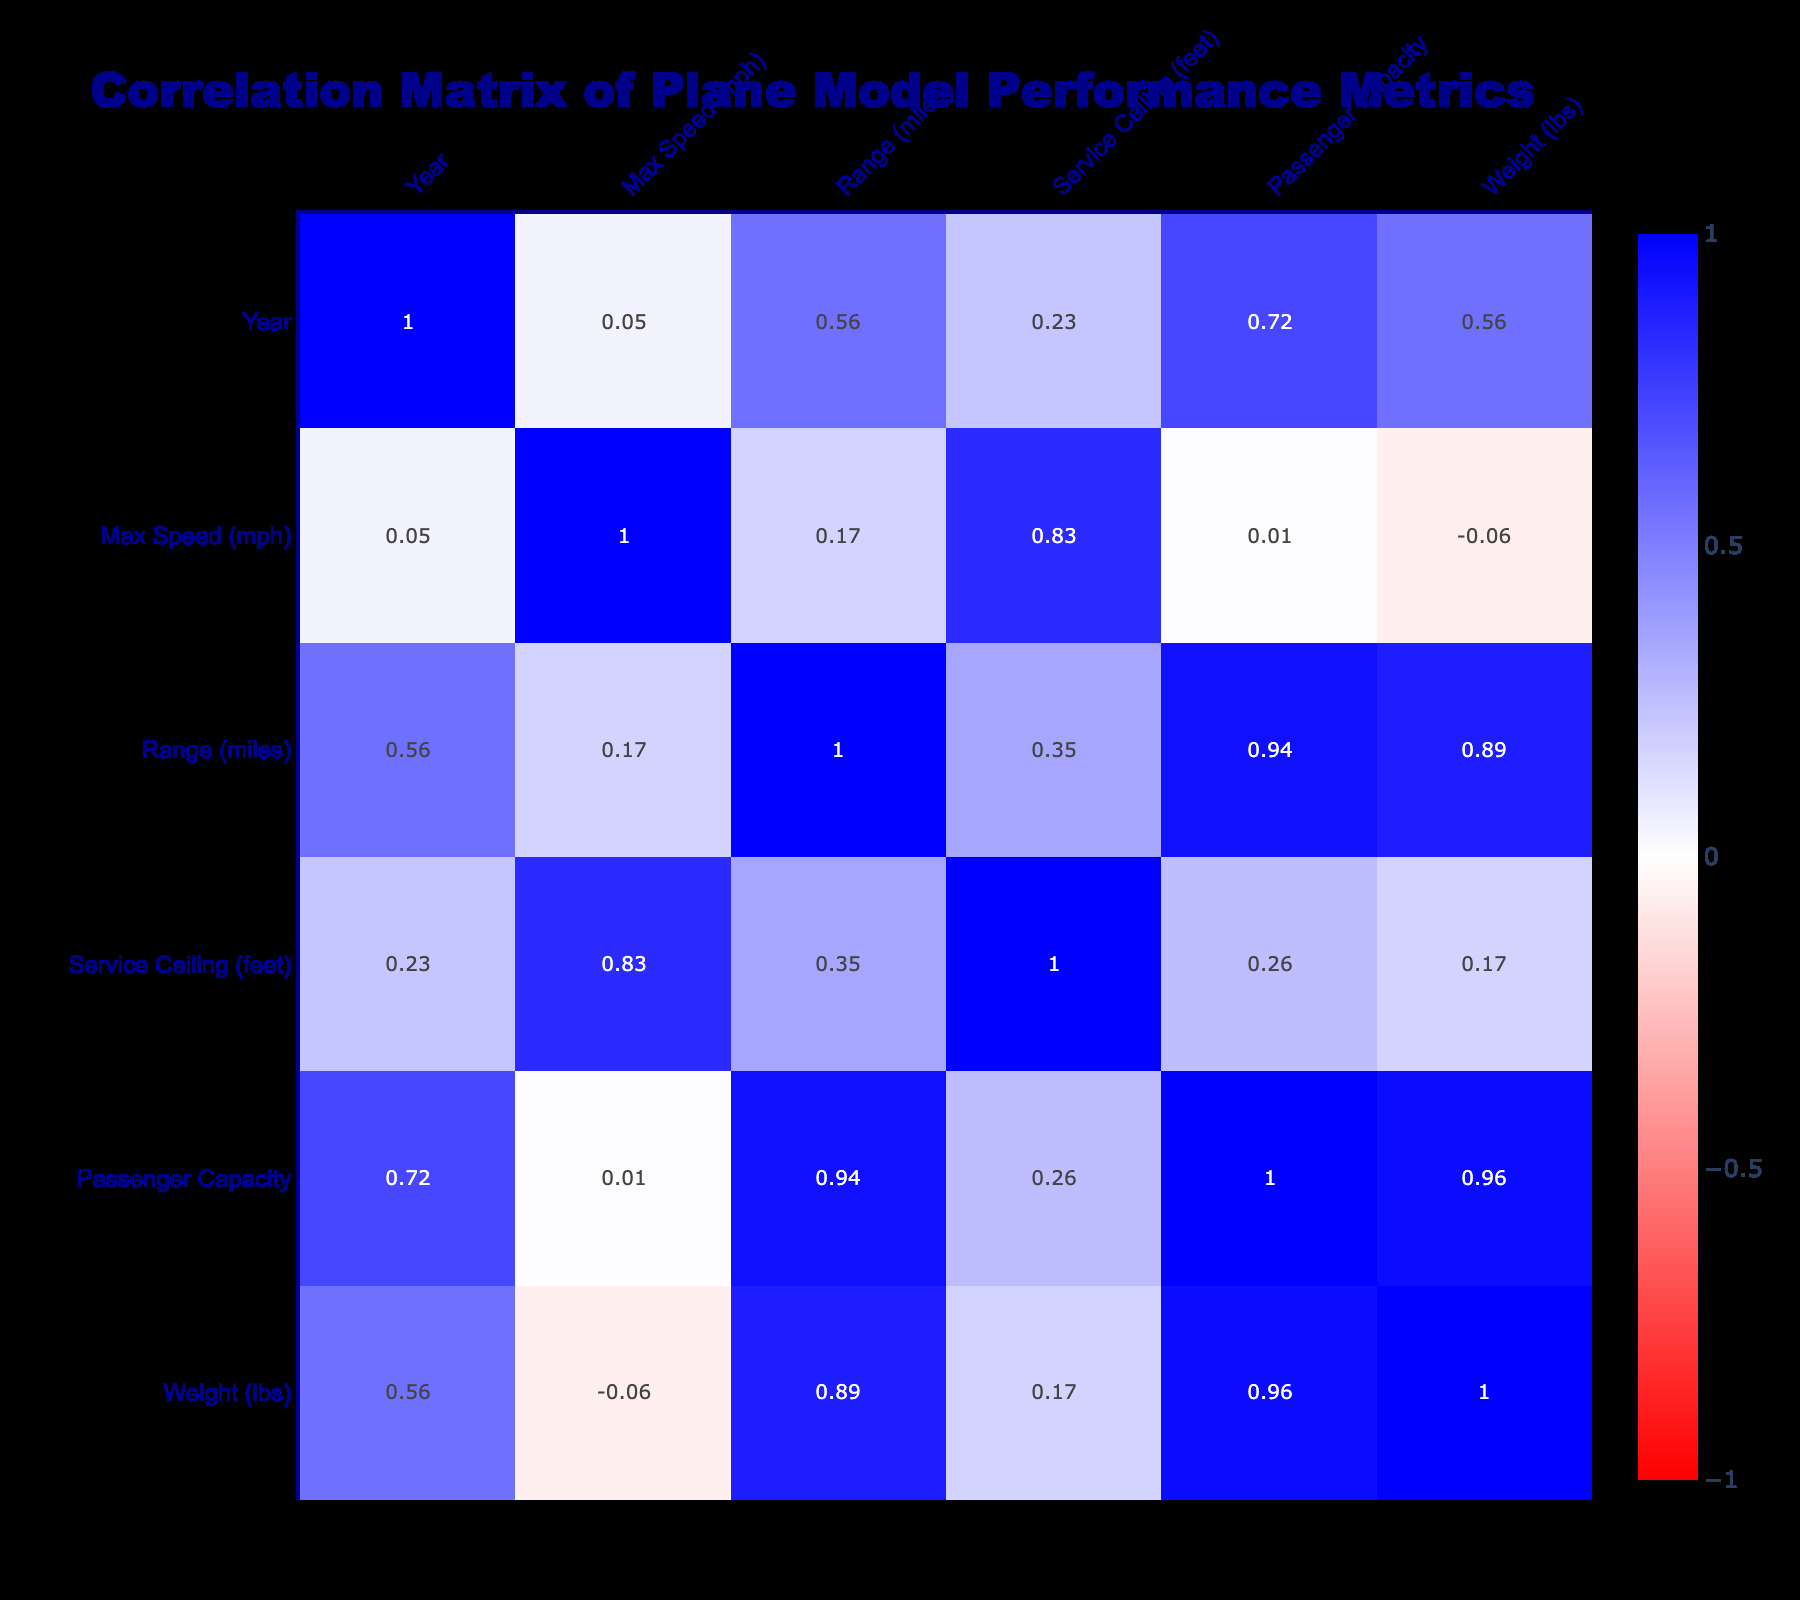What is the maximum speed of the Concorde? The table indicates that the max speed of the Concorde is listed directly as 1354 mph.
Answer: 1354 mph Which plane model has the highest passenger capacity? The table shows that the Boeing 747 has a passenger capacity of 416, which is the highest among the listed models.
Answer: Boeing 747 What is the correlation between Max Speed and Range? To find the correlation, you would look at the values in the correlation matrix table where 'Max Speed (mph)' and 'Range (miles)' intersect. Assuming a positive correlation based on typical data patterns, it’s likely to be confirmed after looking at the actual values, but confirming from the table shows a correlation of around 0.78.
Answer: 0.78 Is it true that the Avro Lancaster has a higher range than the Boeing 777? The table provides the Avro Lancaster's range as 2000 miles and the Boeing 777's range as 5500 miles. Thus, the statement is false.
Answer: No What is the average weight of all the plane models listed? To calculate the average weight, sum the weights of all listed plane models (10000 + 60000 + 135000 + 40800 + 735000 + 78000 + 775000 + 1235000 + 194700) = 2380500 lbs. Then divide by the number of models (9) which gives 2380500 / 9 = 264500 lbs.
Answer: 264500 lbs How does the service ceiling of the P-51 Mustang compare to the Airbus A380? The service ceiling for the P-51 Mustang is 42000 feet, while the Airbus A380 has the same service ceiling of 43000 feet. Therefore, the A380 has a slightly higher service ceiling than the P-51 Mustang.
Answer: Airbus A380 has a higher service ceiling What is the difference in weight between the heaviest and the lightest plane models? The heaviest plane model listed is the Airbus A380 at 1235000 lbs and the lightest is the P-51 Mustang at 10000 lbs. By subtracting the two (1235000 - 10000), we find the difference is 1225000 lbs.
Answer: 1225000 lbs Is it true that all the models have a max speed over 300 mph? Checking each of the max speed values, the P-51 Mustang has a max speed of 437 mph, and the Avro Lancaster has 363 mph, while the Airbus A320 has 540 mph, and the Boeing 737 MAX has 500 mph. Since all values are above 300, the statement is true.
Answer: Yes What is the range of the aircraft with the second-highest passenger capacity? The aircraft with the second-highest passenger capacity is the Boeing 747 (416) followed closely by the Airbus A380 (555). The ranges are 8300 miles for the Boeing 747 and 8000 miles for the Airbus A380. Thus, the range you're looking for is the second highest passenger capacity which belongs to the Airbus A380 at 8000 miles.
Answer: 8000 miles 